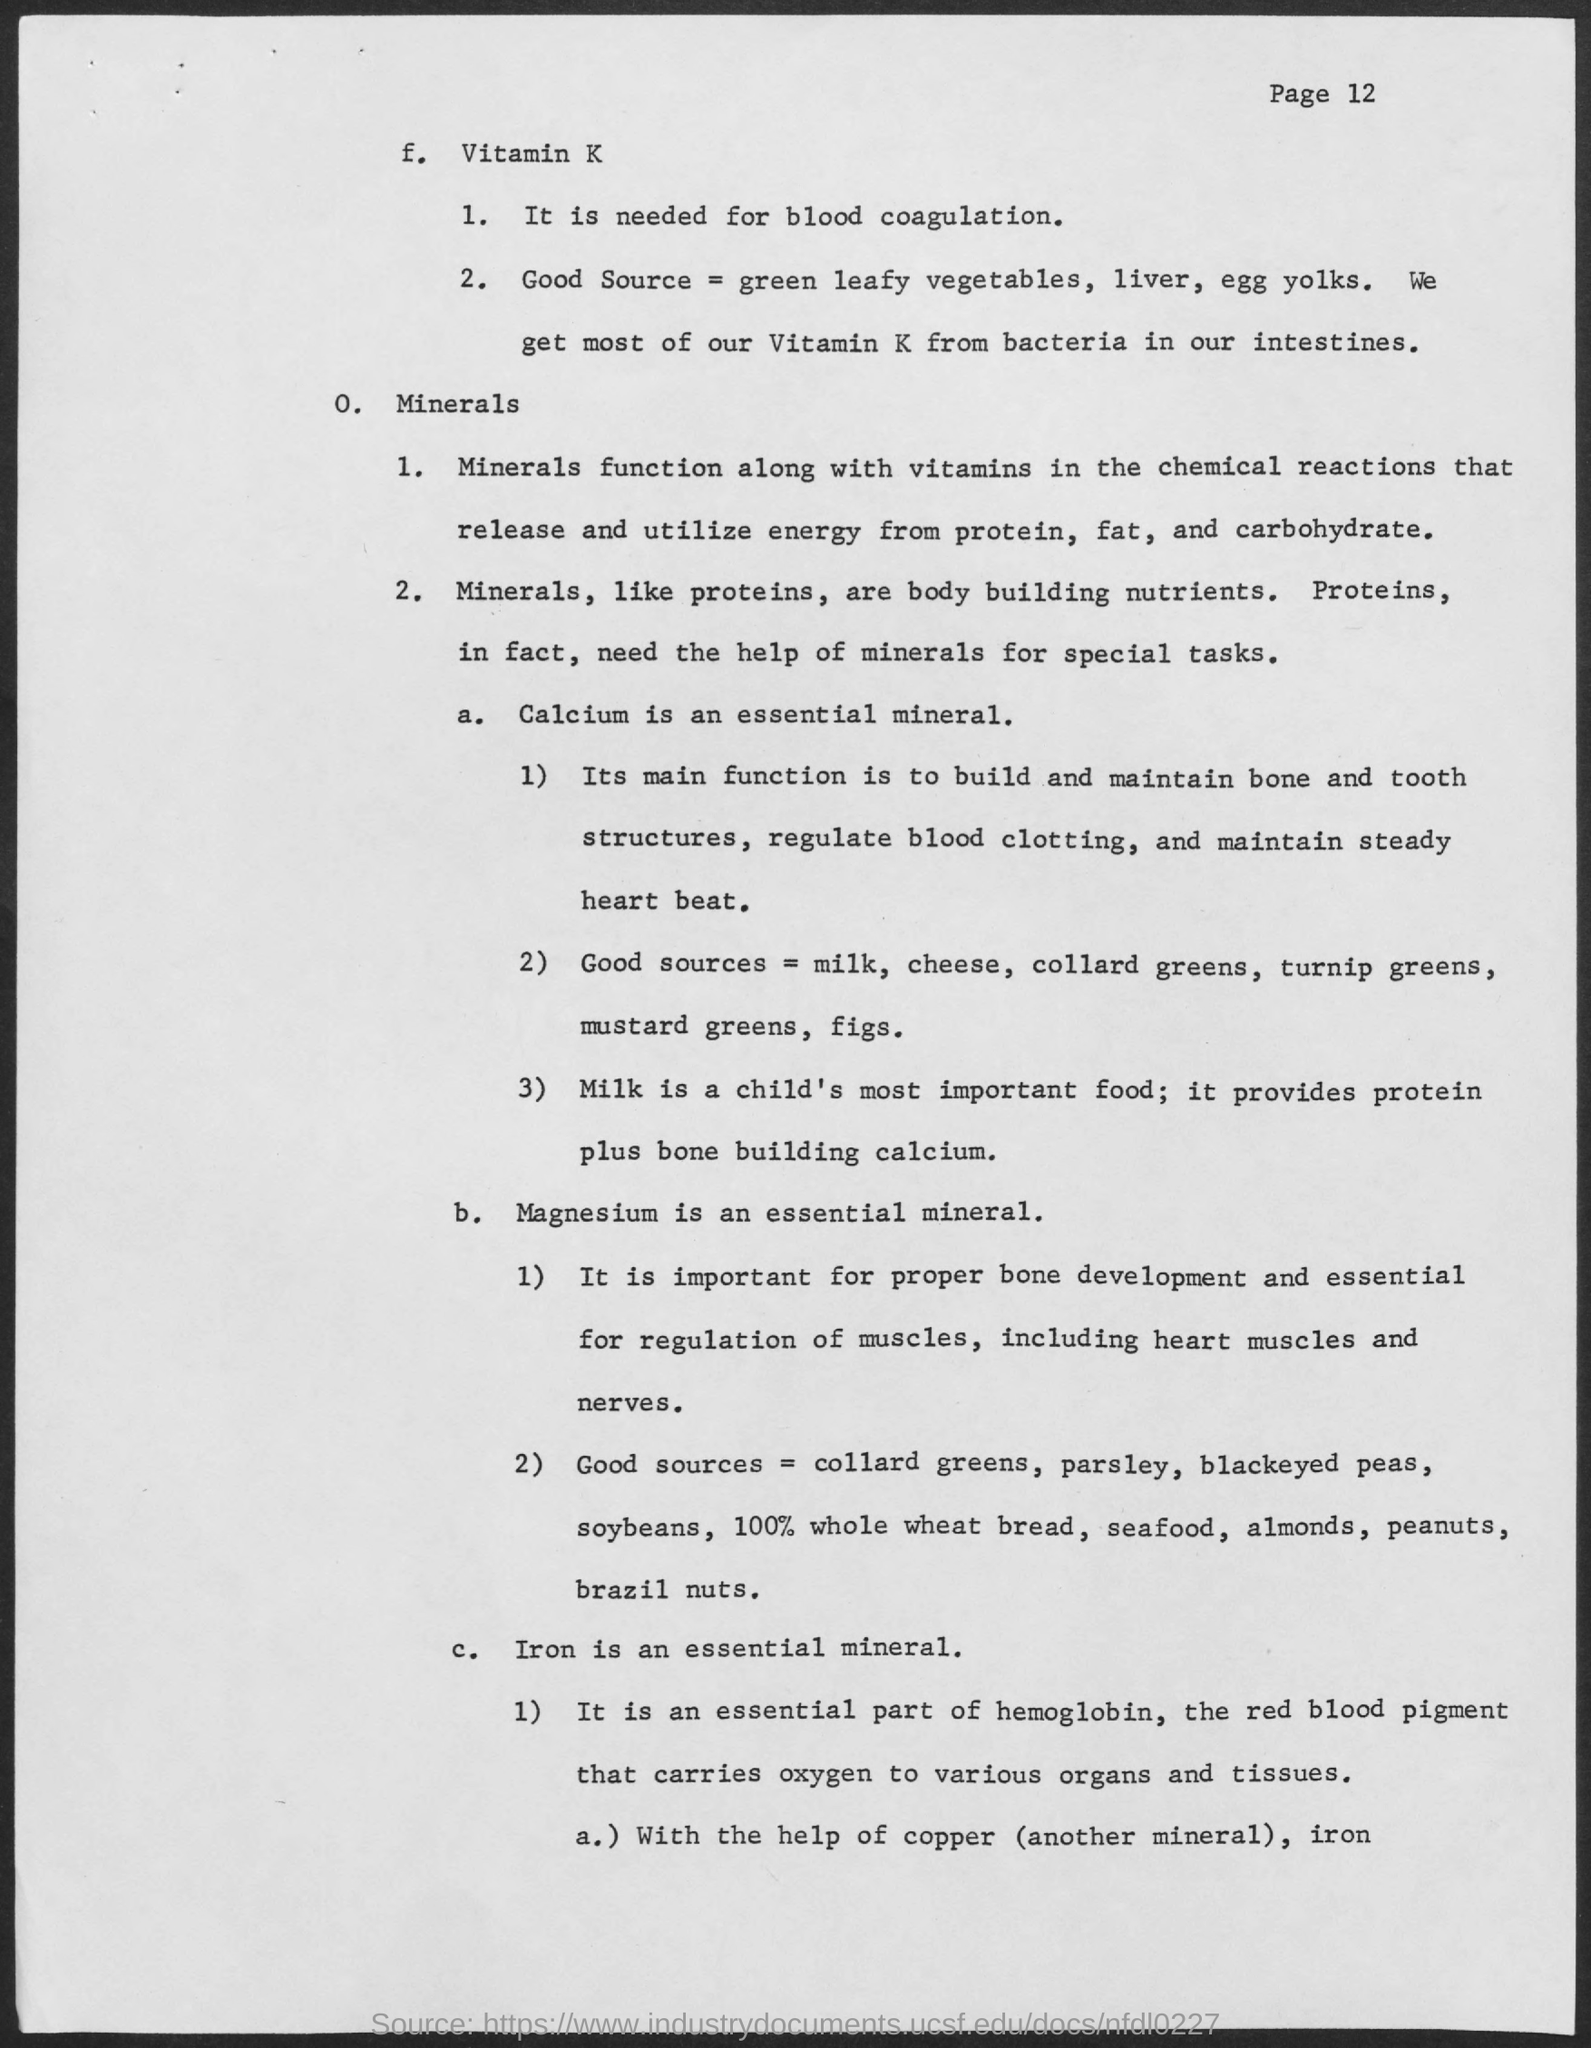Draw attention to some important aspects in this diagram. The primary source of calcium for children is milk. Calcium is necessary for maintaining a consistent and regular heartbeat. Iron is the mineral that is primarily found in hemoglobin. Magnesium is essential for the development of strong and healthy bones. 